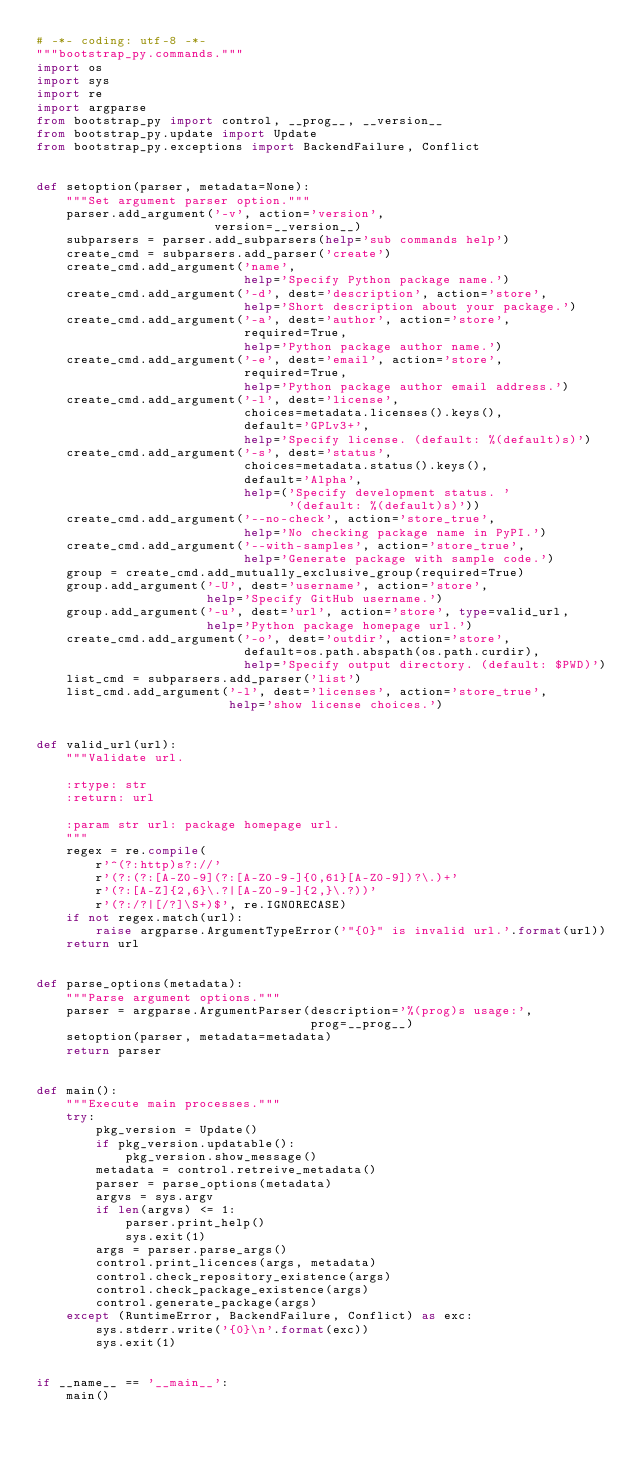<code> <loc_0><loc_0><loc_500><loc_500><_Python_># -*- coding: utf-8 -*-
"""bootstrap_py.commands."""
import os
import sys
import re
import argparse
from bootstrap_py import control, __prog__, __version__
from bootstrap_py.update import Update
from bootstrap_py.exceptions import BackendFailure, Conflict


def setoption(parser, metadata=None):
    """Set argument parser option."""
    parser.add_argument('-v', action='version',
                        version=__version__)
    subparsers = parser.add_subparsers(help='sub commands help')
    create_cmd = subparsers.add_parser('create')
    create_cmd.add_argument('name',
                            help='Specify Python package name.')
    create_cmd.add_argument('-d', dest='description', action='store',
                            help='Short description about your package.')
    create_cmd.add_argument('-a', dest='author', action='store',
                            required=True,
                            help='Python package author name.')
    create_cmd.add_argument('-e', dest='email', action='store',
                            required=True,
                            help='Python package author email address.')
    create_cmd.add_argument('-l', dest='license',
                            choices=metadata.licenses().keys(),
                            default='GPLv3+',
                            help='Specify license. (default: %(default)s)')
    create_cmd.add_argument('-s', dest='status',
                            choices=metadata.status().keys(),
                            default='Alpha',
                            help=('Specify development status. '
                                  '(default: %(default)s)'))
    create_cmd.add_argument('--no-check', action='store_true',
                            help='No checking package name in PyPI.')
    create_cmd.add_argument('--with-samples', action='store_true',
                            help='Generate package with sample code.')
    group = create_cmd.add_mutually_exclusive_group(required=True)
    group.add_argument('-U', dest='username', action='store',
                       help='Specify GitHub username.')
    group.add_argument('-u', dest='url', action='store', type=valid_url,
                       help='Python package homepage url.')
    create_cmd.add_argument('-o', dest='outdir', action='store',
                            default=os.path.abspath(os.path.curdir),
                            help='Specify output directory. (default: $PWD)')
    list_cmd = subparsers.add_parser('list')
    list_cmd.add_argument('-l', dest='licenses', action='store_true',
                          help='show license choices.')


def valid_url(url):
    """Validate url.

    :rtype: str
    :return: url

    :param str url: package homepage url.
    """
    regex = re.compile(
        r'^(?:http)s?://'
        r'(?:(?:[A-Z0-9](?:[A-Z0-9-]{0,61}[A-Z0-9])?\.)+'
        r'(?:[A-Z]{2,6}\.?|[A-Z0-9-]{2,}\.?))'
        r'(?:/?|[/?]\S+)$', re.IGNORECASE)
    if not regex.match(url):
        raise argparse.ArgumentTypeError('"{0}" is invalid url.'.format(url))
    return url


def parse_options(metadata):
    """Parse argument options."""
    parser = argparse.ArgumentParser(description='%(prog)s usage:',
                                     prog=__prog__)
    setoption(parser, metadata=metadata)
    return parser


def main():
    """Execute main processes."""
    try:
        pkg_version = Update()
        if pkg_version.updatable():
            pkg_version.show_message()
        metadata = control.retreive_metadata()
        parser = parse_options(metadata)
        argvs = sys.argv
        if len(argvs) <= 1:
            parser.print_help()
            sys.exit(1)
        args = parser.parse_args()
        control.print_licences(args, metadata)
        control.check_repository_existence(args)
        control.check_package_existence(args)
        control.generate_package(args)
    except (RuntimeError, BackendFailure, Conflict) as exc:
        sys.stderr.write('{0}\n'.format(exc))
        sys.exit(1)


if __name__ == '__main__':
    main()
</code> 